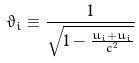<formula> <loc_0><loc_0><loc_500><loc_500>\vartheta _ { i } \equiv \frac { 1 } { \sqrt { 1 - \frac { u _ { i } + u _ { i } } { c ^ { 2 } } } }</formula> 